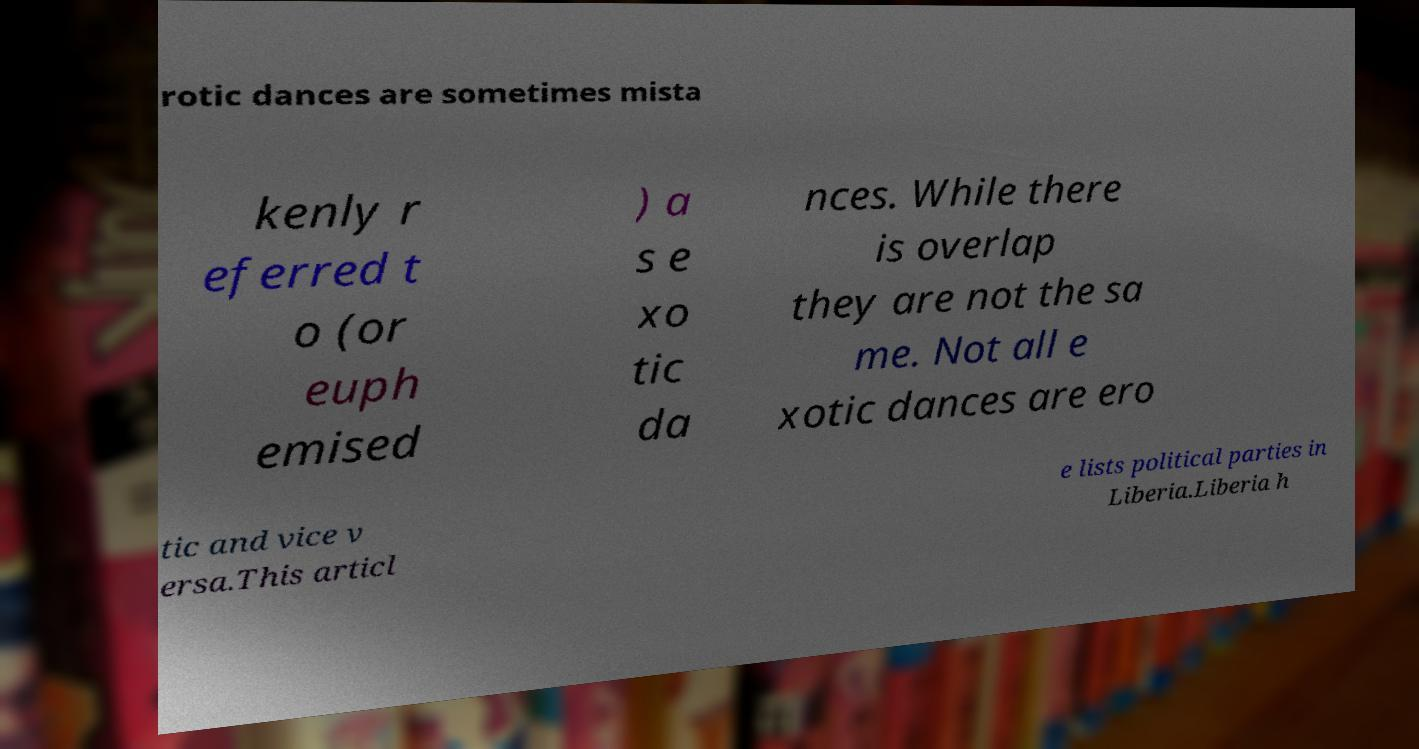For documentation purposes, I need the text within this image transcribed. Could you provide that? rotic dances are sometimes mista kenly r eferred t o (or euph emised ) a s e xo tic da nces. While there is overlap they are not the sa me. Not all e xotic dances are ero tic and vice v ersa.This articl e lists political parties in Liberia.Liberia h 